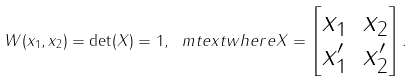<formula> <loc_0><loc_0><loc_500><loc_500>W ( x _ { 1 } , x _ { 2 } ) = \det ( X ) = 1 , \ m t e x t { w h e r e } X = \begin{bmatrix} x _ { 1 } & x _ { 2 } \\ x _ { 1 } ^ { \prime } & x _ { 2 } ^ { \prime } \end{bmatrix} .</formula> 